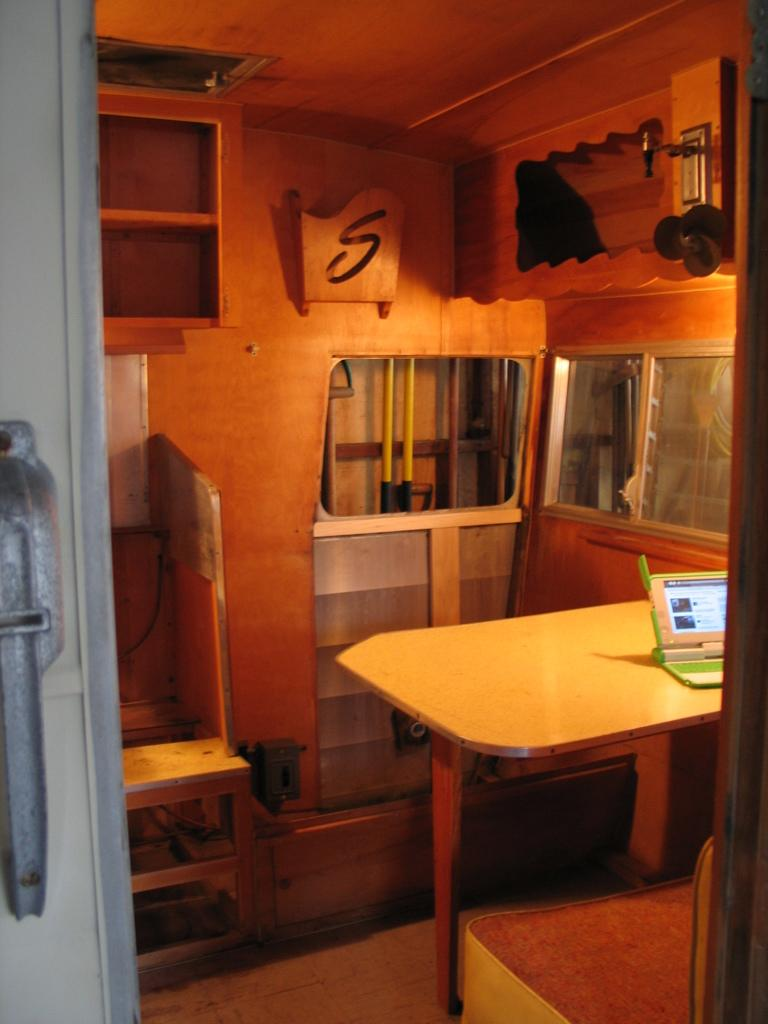What type of furniture is present in the image? There is a table and a chair in the image. What is the purpose of the seat in front of the table? The seat in front of the table is likely for someone to sit and use the table. What electronic device is on the table? There is a laptop on the table. What else can be seen behind the table in the image? There are other objects visible behind the table. What direction is the glove facing in the image? There is no glove present in the image, so it is not possible to determine the direction it might be facing. 